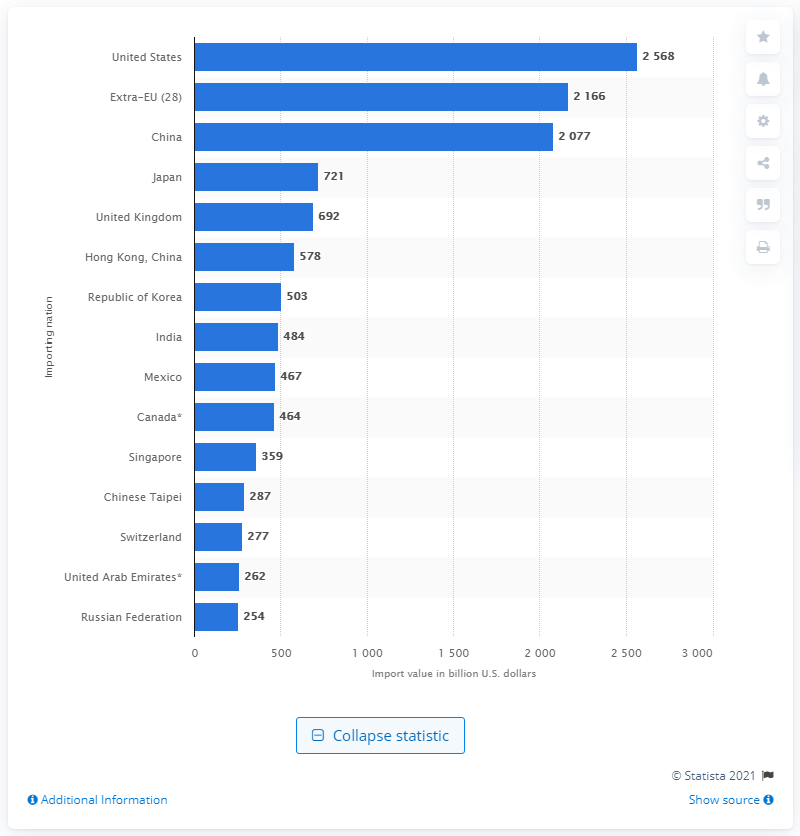Point out several critical features in this image. The largest importer of merchandise in the world in 2019 was valued at 25,688. 